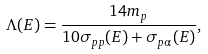<formula> <loc_0><loc_0><loc_500><loc_500>\Lambda ( E ) = \frac { 1 4 m _ { p } } { 1 0 \sigma _ { p p } ( E ) + \sigma _ { p \alpha } ( E ) } ,</formula> 